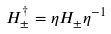Convert formula to latex. <formula><loc_0><loc_0><loc_500><loc_500>H _ { \pm } ^ { \dagger } = \eta H _ { \pm } \eta ^ { - 1 }</formula> 